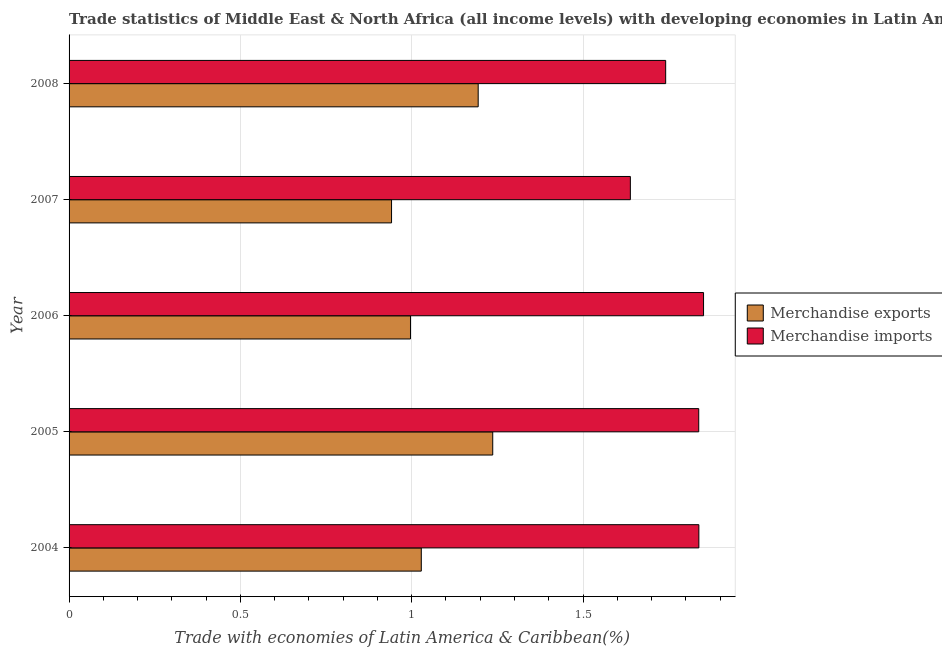How many bars are there on the 4th tick from the bottom?
Offer a very short reply. 2. What is the label of the 5th group of bars from the top?
Your answer should be very brief. 2004. What is the merchandise imports in 2004?
Keep it short and to the point. 1.84. Across all years, what is the maximum merchandise exports?
Make the answer very short. 1.24. Across all years, what is the minimum merchandise exports?
Keep it short and to the point. 0.94. In which year was the merchandise exports minimum?
Keep it short and to the point. 2007. What is the total merchandise exports in the graph?
Offer a very short reply. 5.4. What is the difference between the merchandise imports in 2007 and that in 2008?
Provide a short and direct response. -0.1. What is the difference between the merchandise imports in 2006 and the merchandise exports in 2004?
Your answer should be very brief. 0.82. What is the average merchandise exports per year?
Make the answer very short. 1.08. In the year 2006, what is the difference between the merchandise imports and merchandise exports?
Provide a short and direct response. 0.85. In how many years, is the merchandise imports greater than 1.8 %?
Your answer should be very brief. 3. What is the ratio of the merchandise exports in 2005 to that in 2007?
Offer a very short reply. 1.31. Is the difference between the merchandise imports in 2005 and 2006 greater than the difference between the merchandise exports in 2005 and 2006?
Provide a short and direct response. No. What is the difference between the highest and the second highest merchandise imports?
Your answer should be very brief. 0.01. What does the 2nd bar from the top in 2007 represents?
Offer a very short reply. Merchandise exports. Are all the bars in the graph horizontal?
Keep it short and to the point. Yes. How many years are there in the graph?
Provide a succinct answer. 5. Are the values on the major ticks of X-axis written in scientific E-notation?
Keep it short and to the point. No. Does the graph contain any zero values?
Offer a very short reply. No. Does the graph contain grids?
Make the answer very short. Yes. Where does the legend appear in the graph?
Offer a terse response. Center right. How are the legend labels stacked?
Keep it short and to the point. Vertical. What is the title of the graph?
Your answer should be very brief. Trade statistics of Middle East & North Africa (all income levels) with developing economies in Latin America. What is the label or title of the X-axis?
Ensure brevity in your answer.  Trade with economies of Latin America & Caribbean(%). What is the label or title of the Y-axis?
Make the answer very short. Year. What is the Trade with economies of Latin America & Caribbean(%) of Merchandise exports in 2004?
Offer a very short reply. 1.03. What is the Trade with economies of Latin America & Caribbean(%) of Merchandise imports in 2004?
Provide a short and direct response. 1.84. What is the Trade with economies of Latin America & Caribbean(%) of Merchandise exports in 2005?
Give a very brief answer. 1.24. What is the Trade with economies of Latin America & Caribbean(%) of Merchandise imports in 2005?
Provide a short and direct response. 1.84. What is the Trade with economies of Latin America & Caribbean(%) of Merchandise exports in 2006?
Keep it short and to the point. 1. What is the Trade with economies of Latin America & Caribbean(%) in Merchandise imports in 2006?
Keep it short and to the point. 1.85. What is the Trade with economies of Latin America & Caribbean(%) in Merchandise exports in 2007?
Provide a short and direct response. 0.94. What is the Trade with economies of Latin America & Caribbean(%) in Merchandise imports in 2007?
Your answer should be very brief. 1.64. What is the Trade with economies of Latin America & Caribbean(%) in Merchandise exports in 2008?
Offer a very short reply. 1.19. What is the Trade with economies of Latin America & Caribbean(%) of Merchandise imports in 2008?
Provide a short and direct response. 1.74. Across all years, what is the maximum Trade with economies of Latin America & Caribbean(%) of Merchandise exports?
Offer a terse response. 1.24. Across all years, what is the maximum Trade with economies of Latin America & Caribbean(%) in Merchandise imports?
Provide a short and direct response. 1.85. Across all years, what is the minimum Trade with economies of Latin America & Caribbean(%) in Merchandise exports?
Offer a terse response. 0.94. Across all years, what is the minimum Trade with economies of Latin America & Caribbean(%) of Merchandise imports?
Provide a short and direct response. 1.64. What is the total Trade with economies of Latin America & Caribbean(%) of Merchandise exports in the graph?
Your response must be concise. 5.4. What is the total Trade with economies of Latin America & Caribbean(%) in Merchandise imports in the graph?
Your answer should be compact. 8.91. What is the difference between the Trade with economies of Latin America & Caribbean(%) of Merchandise exports in 2004 and that in 2005?
Your response must be concise. -0.21. What is the difference between the Trade with economies of Latin America & Caribbean(%) of Merchandise imports in 2004 and that in 2005?
Your response must be concise. 0. What is the difference between the Trade with economies of Latin America & Caribbean(%) of Merchandise exports in 2004 and that in 2006?
Provide a succinct answer. 0.03. What is the difference between the Trade with economies of Latin America & Caribbean(%) in Merchandise imports in 2004 and that in 2006?
Offer a very short reply. -0.01. What is the difference between the Trade with economies of Latin America & Caribbean(%) in Merchandise exports in 2004 and that in 2007?
Offer a terse response. 0.09. What is the difference between the Trade with economies of Latin America & Caribbean(%) of Merchandise imports in 2004 and that in 2007?
Provide a succinct answer. 0.2. What is the difference between the Trade with economies of Latin America & Caribbean(%) in Merchandise exports in 2004 and that in 2008?
Keep it short and to the point. -0.17. What is the difference between the Trade with economies of Latin America & Caribbean(%) in Merchandise imports in 2004 and that in 2008?
Ensure brevity in your answer.  0.1. What is the difference between the Trade with economies of Latin America & Caribbean(%) of Merchandise exports in 2005 and that in 2006?
Keep it short and to the point. 0.24. What is the difference between the Trade with economies of Latin America & Caribbean(%) in Merchandise imports in 2005 and that in 2006?
Your answer should be compact. -0.01. What is the difference between the Trade with economies of Latin America & Caribbean(%) in Merchandise exports in 2005 and that in 2007?
Give a very brief answer. 0.3. What is the difference between the Trade with economies of Latin America & Caribbean(%) in Merchandise imports in 2005 and that in 2007?
Make the answer very short. 0.2. What is the difference between the Trade with economies of Latin America & Caribbean(%) of Merchandise exports in 2005 and that in 2008?
Your answer should be very brief. 0.04. What is the difference between the Trade with economies of Latin America & Caribbean(%) of Merchandise imports in 2005 and that in 2008?
Give a very brief answer. 0.1. What is the difference between the Trade with economies of Latin America & Caribbean(%) in Merchandise exports in 2006 and that in 2007?
Give a very brief answer. 0.06. What is the difference between the Trade with economies of Latin America & Caribbean(%) in Merchandise imports in 2006 and that in 2007?
Keep it short and to the point. 0.21. What is the difference between the Trade with economies of Latin America & Caribbean(%) of Merchandise exports in 2006 and that in 2008?
Your answer should be very brief. -0.2. What is the difference between the Trade with economies of Latin America & Caribbean(%) in Merchandise imports in 2006 and that in 2008?
Offer a terse response. 0.11. What is the difference between the Trade with economies of Latin America & Caribbean(%) of Merchandise exports in 2007 and that in 2008?
Make the answer very short. -0.25. What is the difference between the Trade with economies of Latin America & Caribbean(%) in Merchandise imports in 2007 and that in 2008?
Offer a terse response. -0.1. What is the difference between the Trade with economies of Latin America & Caribbean(%) of Merchandise exports in 2004 and the Trade with economies of Latin America & Caribbean(%) of Merchandise imports in 2005?
Your answer should be compact. -0.81. What is the difference between the Trade with economies of Latin America & Caribbean(%) of Merchandise exports in 2004 and the Trade with economies of Latin America & Caribbean(%) of Merchandise imports in 2006?
Your answer should be very brief. -0.82. What is the difference between the Trade with economies of Latin America & Caribbean(%) of Merchandise exports in 2004 and the Trade with economies of Latin America & Caribbean(%) of Merchandise imports in 2007?
Provide a short and direct response. -0.61. What is the difference between the Trade with economies of Latin America & Caribbean(%) in Merchandise exports in 2004 and the Trade with economies of Latin America & Caribbean(%) in Merchandise imports in 2008?
Provide a short and direct response. -0.71. What is the difference between the Trade with economies of Latin America & Caribbean(%) of Merchandise exports in 2005 and the Trade with economies of Latin America & Caribbean(%) of Merchandise imports in 2006?
Keep it short and to the point. -0.62. What is the difference between the Trade with economies of Latin America & Caribbean(%) of Merchandise exports in 2005 and the Trade with economies of Latin America & Caribbean(%) of Merchandise imports in 2007?
Make the answer very short. -0.4. What is the difference between the Trade with economies of Latin America & Caribbean(%) of Merchandise exports in 2005 and the Trade with economies of Latin America & Caribbean(%) of Merchandise imports in 2008?
Your answer should be compact. -0.5. What is the difference between the Trade with economies of Latin America & Caribbean(%) in Merchandise exports in 2006 and the Trade with economies of Latin America & Caribbean(%) in Merchandise imports in 2007?
Keep it short and to the point. -0.64. What is the difference between the Trade with economies of Latin America & Caribbean(%) in Merchandise exports in 2006 and the Trade with economies of Latin America & Caribbean(%) in Merchandise imports in 2008?
Your answer should be compact. -0.74. What is the difference between the Trade with economies of Latin America & Caribbean(%) in Merchandise exports in 2007 and the Trade with economies of Latin America & Caribbean(%) in Merchandise imports in 2008?
Provide a succinct answer. -0.8. What is the average Trade with economies of Latin America & Caribbean(%) in Merchandise exports per year?
Make the answer very short. 1.08. What is the average Trade with economies of Latin America & Caribbean(%) in Merchandise imports per year?
Provide a succinct answer. 1.78. In the year 2004, what is the difference between the Trade with economies of Latin America & Caribbean(%) in Merchandise exports and Trade with economies of Latin America & Caribbean(%) in Merchandise imports?
Your answer should be very brief. -0.81. In the year 2005, what is the difference between the Trade with economies of Latin America & Caribbean(%) of Merchandise exports and Trade with economies of Latin America & Caribbean(%) of Merchandise imports?
Give a very brief answer. -0.6. In the year 2006, what is the difference between the Trade with economies of Latin America & Caribbean(%) in Merchandise exports and Trade with economies of Latin America & Caribbean(%) in Merchandise imports?
Ensure brevity in your answer.  -0.86. In the year 2007, what is the difference between the Trade with economies of Latin America & Caribbean(%) of Merchandise exports and Trade with economies of Latin America & Caribbean(%) of Merchandise imports?
Provide a succinct answer. -0.7. In the year 2008, what is the difference between the Trade with economies of Latin America & Caribbean(%) in Merchandise exports and Trade with economies of Latin America & Caribbean(%) in Merchandise imports?
Provide a short and direct response. -0.55. What is the ratio of the Trade with economies of Latin America & Caribbean(%) of Merchandise exports in 2004 to that in 2005?
Your answer should be very brief. 0.83. What is the ratio of the Trade with economies of Latin America & Caribbean(%) in Merchandise exports in 2004 to that in 2006?
Give a very brief answer. 1.03. What is the ratio of the Trade with economies of Latin America & Caribbean(%) of Merchandise imports in 2004 to that in 2006?
Your answer should be very brief. 0.99. What is the ratio of the Trade with economies of Latin America & Caribbean(%) in Merchandise exports in 2004 to that in 2007?
Make the answer very short. 1.09. What is the ratio of the Trade with economies of Latin America & Caribbean(%) of Merchandise imports in 2004 to that in 2007?
Your answer should be compact. 1.12. What is the ratio of the Trade with economies of Latin America & Caribbean(%) of Merchandise exports in 2004 to that in 2008?
Give a very brief answer. 0.86. What is the ratio of the Trade with economies of Latin America & Caribbean(%) of Merchandise imports in 2004 to that in 2008?
Offer a terse response. 1.06. What is the ratio of the Trade with economies of Latin America & Caribbean(%) of Merchandise exports in 2005 to that in 2006?
Make the answer very short. 1.24. What is the ratio of the Trade with economies of Latin America & Caribbean(%) in Merchandise exports in 2005 to that in 2007?
Offer a very short reply. 1.31. What is the ratio of the Trade with economies of Latin America & Caribbean(%) of Merchandise imports in 2005 to that in 2007?
Provide a short and direct response. 1.12. What is the ratio of the Trade with economies of Latin America & Caribbean(%) of Merchandise exports in 2005 to that in 2008?
Provide a succinct answer. 1.04. What is the ratio of the Trade with economies of Latin America & Caribbean(%) in Merchandise imports in 2005 to that in 2008?
Keep it short and to the point. 1.06. What is the ratio of the Trade with economies of Latin America & Caribbean(%) of Merchandise exports in 2006 to that in 2007?
Ensure brevity in your answer.  1.06. What is the ratio of the Trade with economies of Latin America & Caribbean(%) in Merchandise imports in 2006 to that in 2007?
Offer a very short reply. 1.13. What is the ratio of the Trade with economies of Latin America & Caribbean(%) in Merchandise exports in 2006 to that in 2008?
Your response must be concise. 0.83. What is the ratio of the Trade with economies of Latin America & Caribbean(%) in Merchandise imports in 2006 to that in 2008?
Ensure brevity in your answer.  1.06. What is the ratio of the Trade with economies of Latin America & Caribbean(%) in Merchandise exports in 2007 to that in 2008?
Keep it short and to the point. 0.79. What is the ratio of the Trade with economies of Latin America & Caribbean(%) in Merchandise imports in 2007 to that in 2008?
Your answer should be very brief. 0.94. What is the difference between the highest and the second highest Trade with economies of Latin America & Caribbean(%) of Merchandise exports?
Provide a succinct answer. 0.04. What is the difference between the highest and the second highest Trade with economies of Latin America & Caribbean(%) in Merchandise imports?
Give a very brief answer. 0.01. What is the difference between the highest and the lowest Trade with economies of Latin America & Caribbean(%) in Merchandise exports?
Make the answer very short. 0.3. What is the difference between the highest and the lowest Trade with economies of Latin America & Caribbean(%) of Merchandise imports?
Your response must be concise. 0.21. 